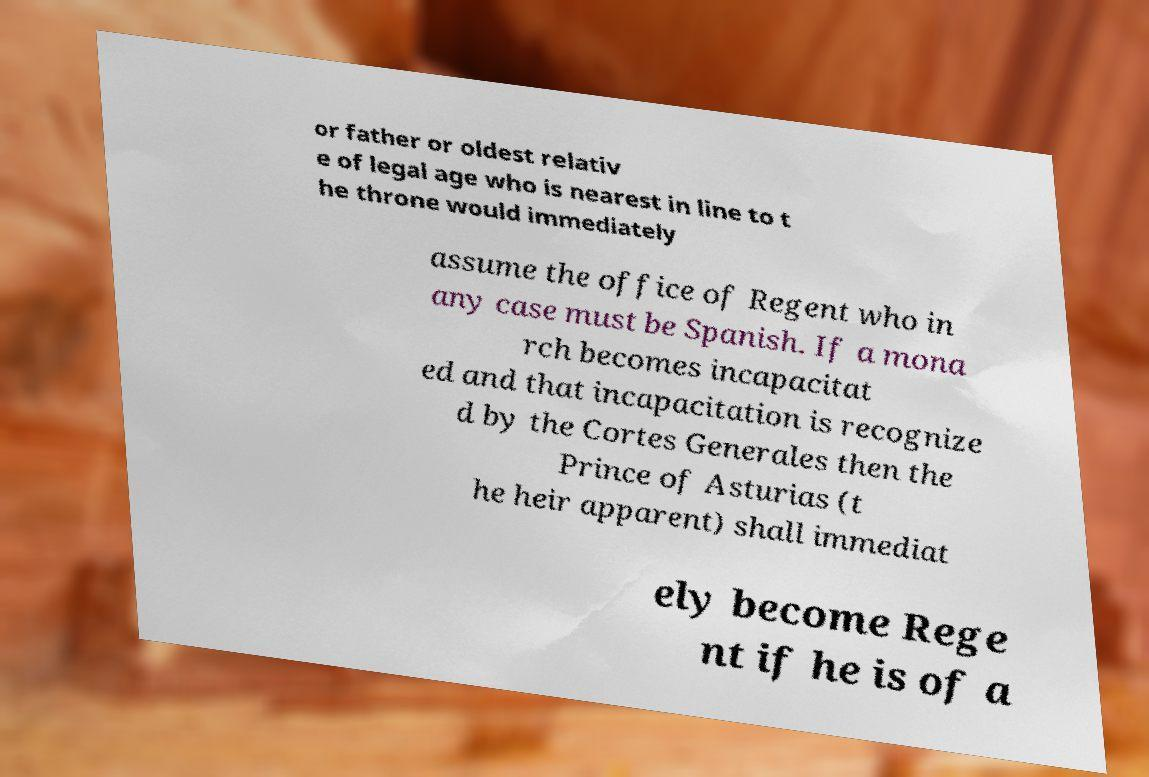What messages or text are displayed in this image? I need them in a readable, typed format. or father or oldest relativ e of legal age who is nearest in line to t he throne would immediately assume the office of Regent who in any case must be Spanish. If a mona rch becomes incapacitat ed and that incapacitation is recognize d by the Cortes Generales then the Prince of Asturias (t he heir apparent) shall immediat ely become Rege nt if he is of a 